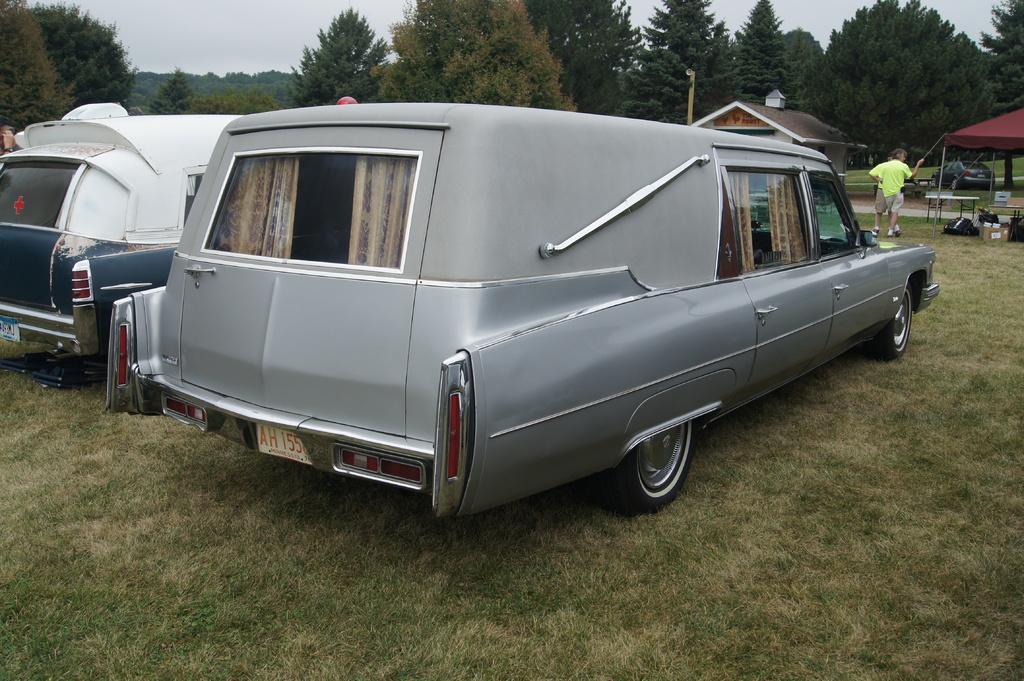How would you summarize this image in a sentence or two? In the foreground of the picture I can see two cars. There is a tent on the right side. I can see the tables and stock boxes on the green grass on the right side. I can see two men standing on the green grass. In the background, I can see a house, a car and trees. There are clouds in the sky. 